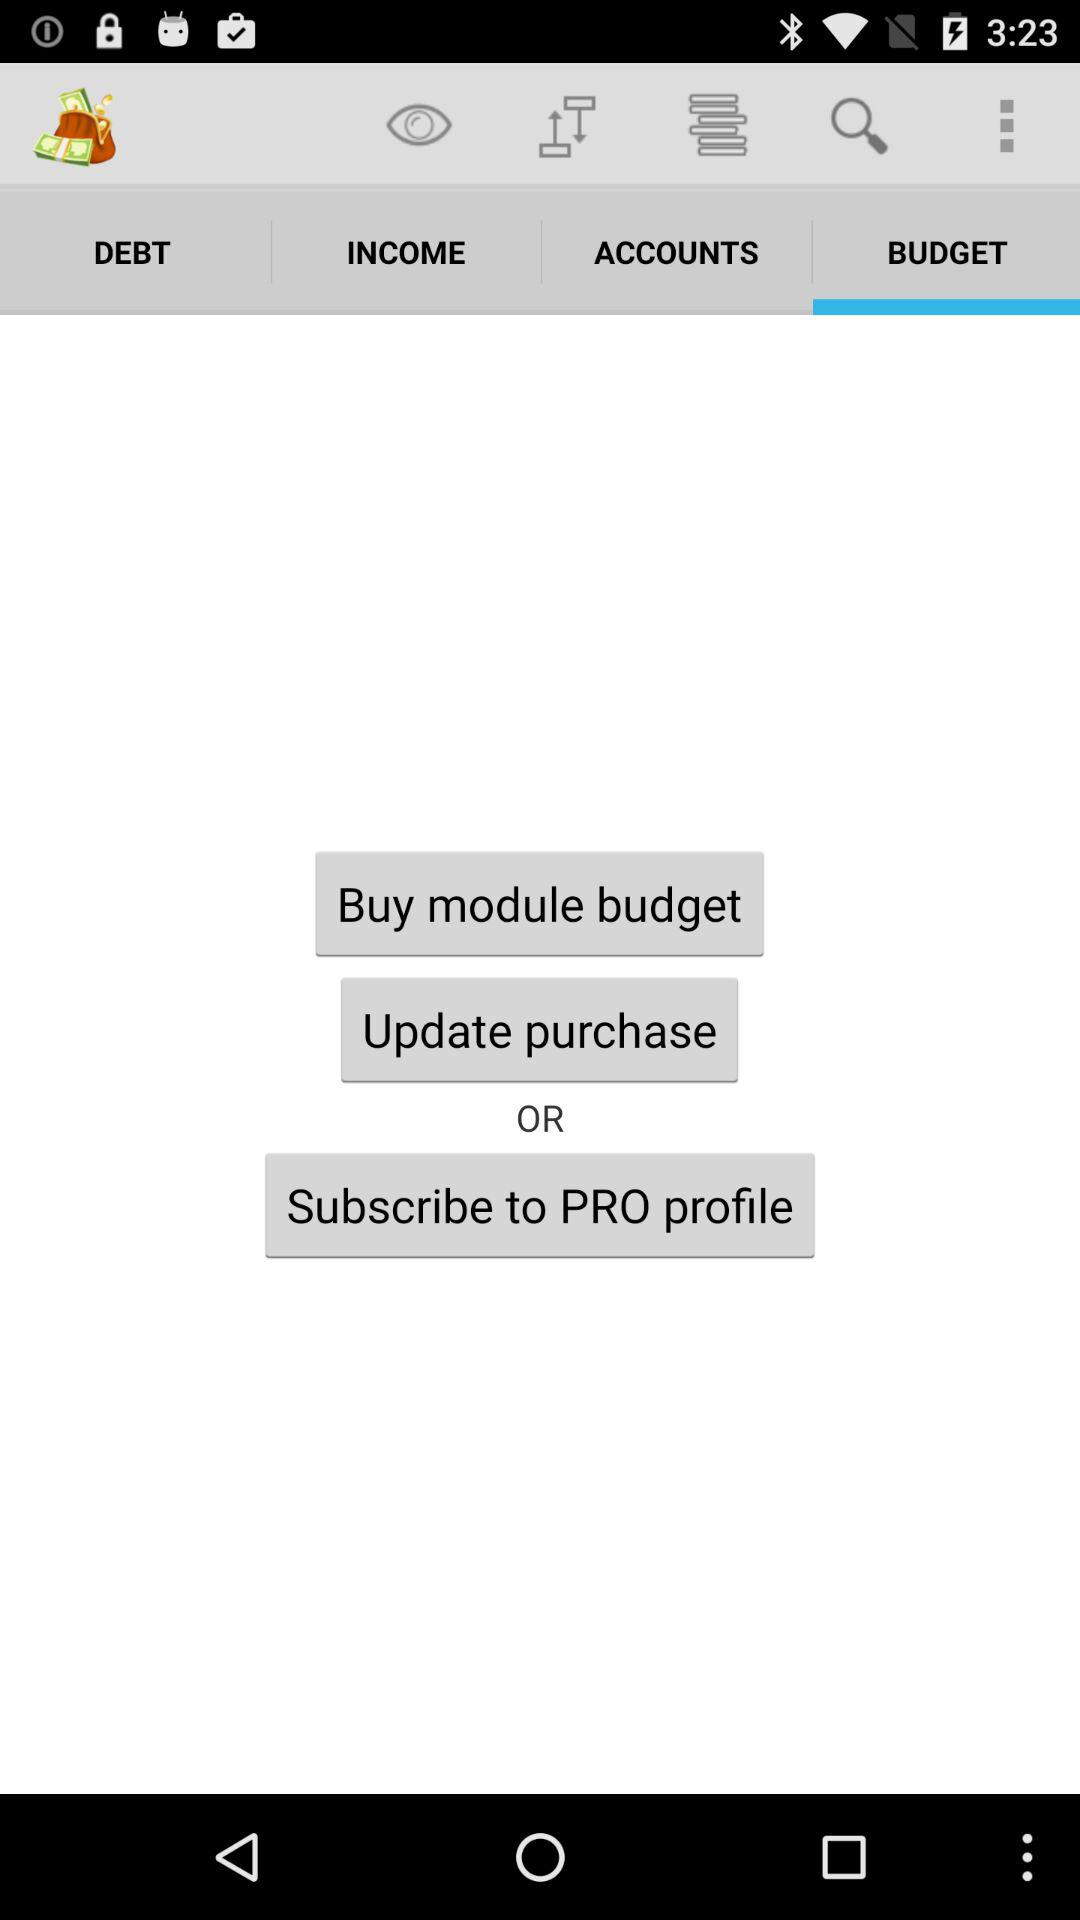Which tab is open? The tab which is open is "BUDGET". 